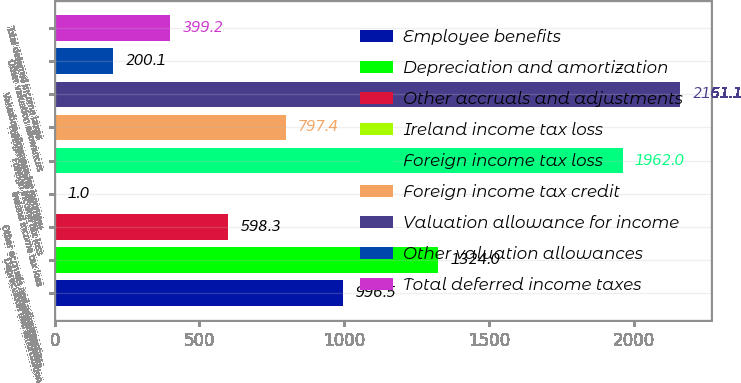<chart> <loc_0><loc_0><loc_500><loc_500><bar_chart><fcel>Employee benefits<fcel>Depreciation and amortization<fcel>Other accruals and adjustments<fcel>Ireland income tax loss<fcel>Foreign income tax loss<fcel>Foreign income tax credit<fcel>Valuation allowance for income<fcel>Other valuation allowances<fcel>Total deferred income taxes<nl><fcel>996.5<fcel>1324<fcel>598.3<fcel>1<fcel>1962<fcel>797.4<fcel>2161.1<fcel>200.1<fcel>399.2<nl></chart> 